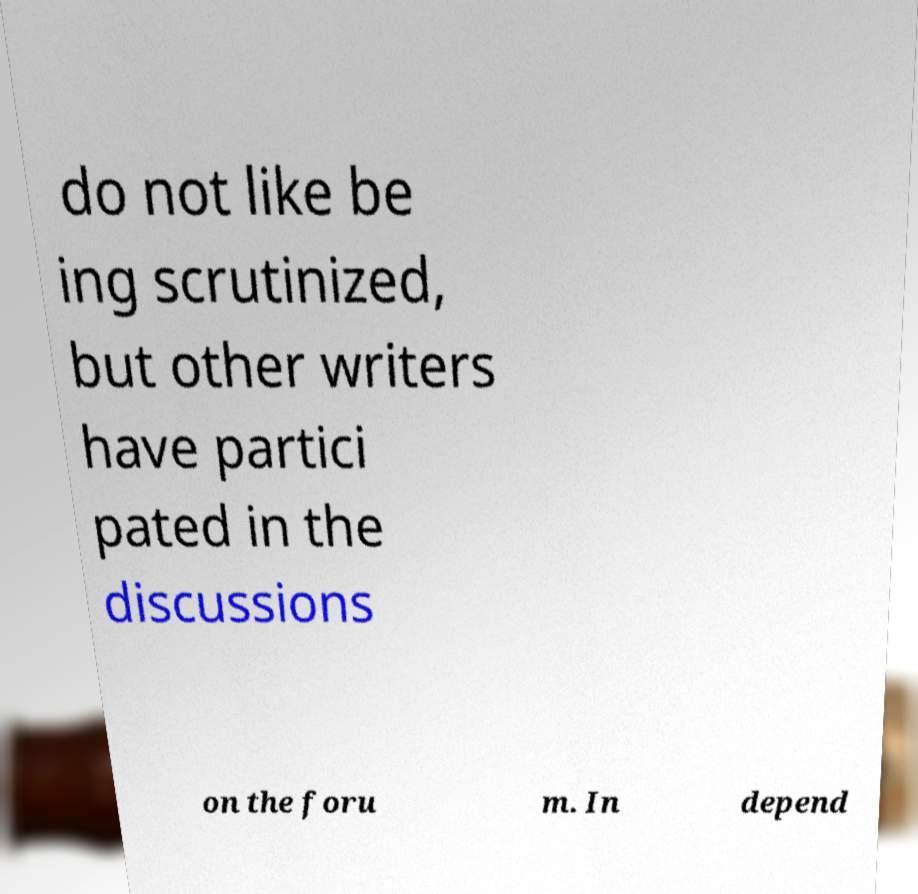There's text embedded in this image that I need extracted. Can you transcribe it verbatim? do not like be ing scrutinized, but other writers have partici pated in the discussions on the foru m. In depend 